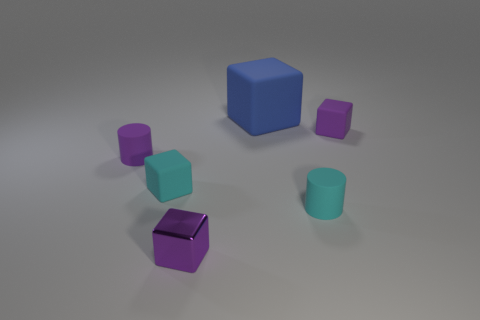Add 4 cyan rubber objects. How many objects exist? 10 Subtract all big blue matte cubes. How many cubes are left? 3 Subtract all purple cylinders. How many purple blocks are left? 2 Subtract 1 blocks. How many blocks are left? 3 Subtract all purple cubes. How many cubes are left? 2 Add 4 blue rubber things. How many blue rubber things exist? 5 Subtract 0 brown blocks. How many objects are left? 6 Subtract all cylinders. How many objects are left? 4 Subtract all gray cylinders. Subtract all green spheres. How many cylinders are left? 2 Subtract all tiny purple metallic balls. Subtract all cyan cylinders. How many objects are left? 5 